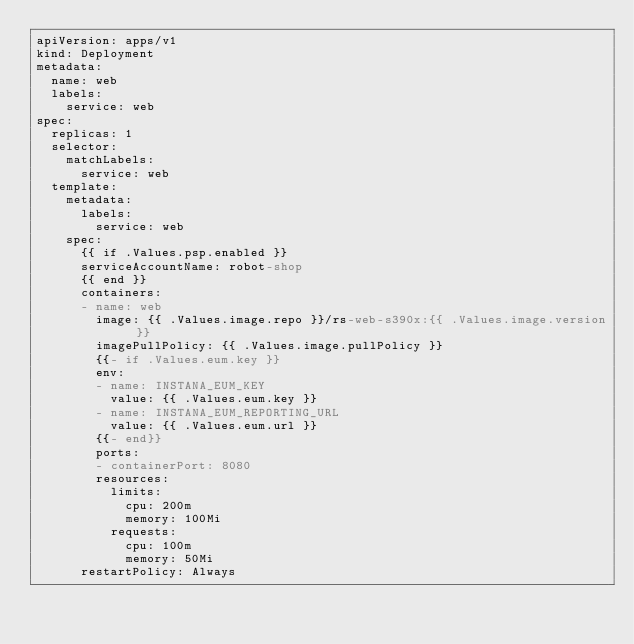Convert code to text. <code><loc_0><loc_0><loc_500><loc_500><_YAML_>apiVersion: apps/v1
kind: Deployment
metadata:
  name: web
  labels:
    service: web
spec:
  replicas: 1
  selector:
    matchLabels:
      service: web
  template:
    metadata:
      labels:
        service: web
    spec:
      {{ if .Values.psp.enabled }}
      serviceAccountName: robot-shop
      {{ end }}
      containers:
      - name: web
        image: {{ .Values.image.repo }}/rs-web-s390x:{{ .Values.image.version }}
        imagePullPolicy: {{ .Values.image.pullPolicy }}
        {{- if .Values.eum.key }}
        env:
        - name: INSTANA_EUM_KEY
          value: {{ .Values.eum.key }}
        - name: INSTANA_EUM_REPORTING_URL
          value: {{ .Values.eum.url }}
        {{- end}}
        ports:
        - containerPort: 8080
        resources:
          limits:
            cpu: 200m
            memory: 100Mi
          requests:
            cpu: 100m
            memory: 50Mi
      restartPolicy: Always
</code> 